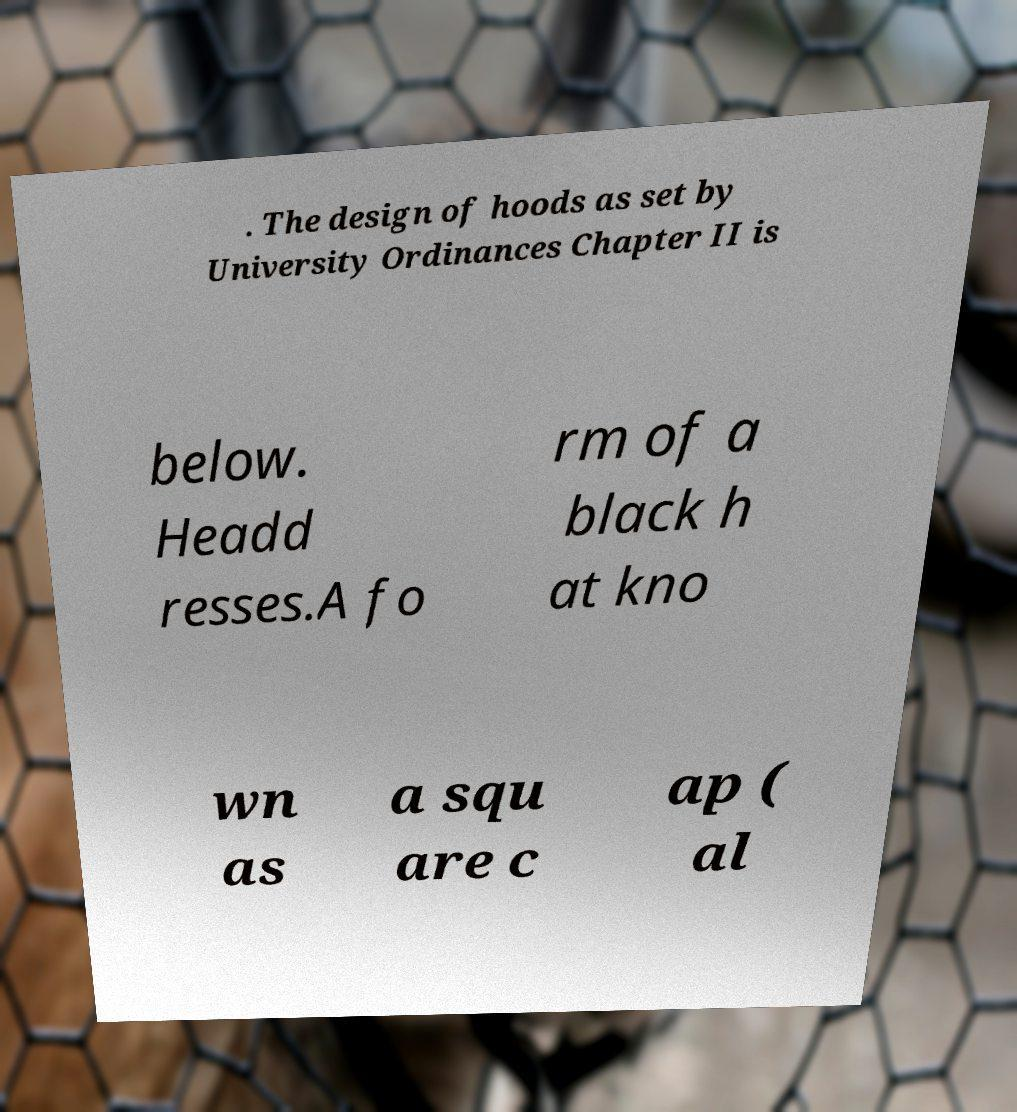What messages or text are displayed in this image? I need them in a readable, typed format. . The design of hoods as set by University Ordinances Chapter II is below. Headd resses.A fo rm of a black h at kno wn as a squ are c ap ( al 